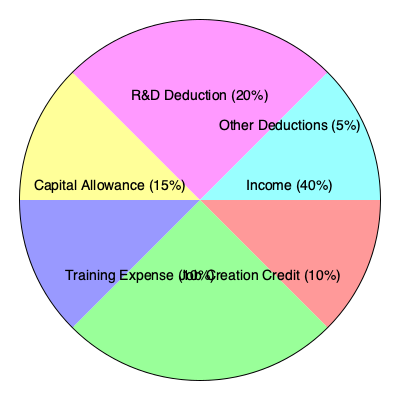Based on the pie chart showing income and deduction components for an SME, calculate the effective tax rate if the statutory corporate tax rate is 25%. Assume the total income is $1,000,000. To calculate the effective tax rate, we need to follow these steps:

1. Calculate the taxable income:
   - Total income: $1,000,000 (40% of the pie chart)
   - Total deductions: 60% of the pie chart
   - Taxable income = Total income - Total deductions
   
   $\text{Taxable Income} = \$1,000,000 - (0.60 \times \$1,000,000 \div 0.40) = \$1,000,000 - \$1,500,000 = -\$500,000$

2. Since the taxable income is negative, the tax payable would be $0.

3. Calculate the effective tax rate:
   $\text{Effective Tax Rate} = \frac{\text{Tax Payable}}{\text{Total Income}} \times 100\%$
   
   $\text{Effective Tax Rate} = \frac{\$0}{\$1,000,000} \times 100\% = 0\%$

Therefore, despite the statutory corporate tax rate of 25%, the effective tax rate for this SME is 0% due to the deductions and credits that exceed the total income.
Answer: 0% 